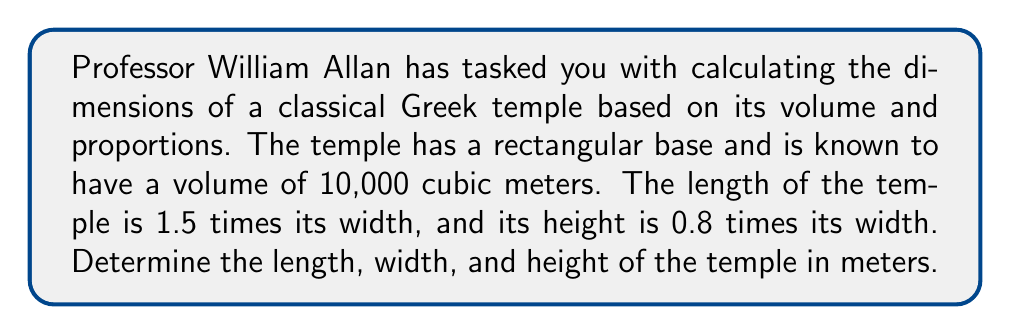Help me with this question. Let's approach this problem step-by-step using a system of equations:

1) Let's define our variables:
   $w$ = width of the temple
   $l$ = length of the temple
   $h$ = height of the temple

2) We're given the following relationships:
   $l = 1.5w$
   $h = 0.8w$

3) We know that the volume of a rectangular prism is given by length × width × height:
   $V = l \times w \times h$

4) Substituting the known volume and the relationships from step 2:
   $10,000 = 1.5w \times w \times 0.8w$

5) Simplify:
   $10,000 = 1.2w^3$

6) Solve for $w$:
   $$w^3 = \frac{10,000}{1.2} = 8,333.33$$
   $$w = \sqrt[3]{8,333.33} \approx 20.28$$

7) Now that we know $w$, we can calculate $l$ and $h$:
   $l = 1.5w = 1.5 \times 20.28 \approx 30.42$
   $h = 0.8w = 0.8 \times 20.28 \approx 16.22$

Thus, we have determined the dimensions of the temple.
Answer: The dimensions of the temple are:
Width: $20.28$ meters
Length: $30.42$ meters
Height: $16.22$ meters 